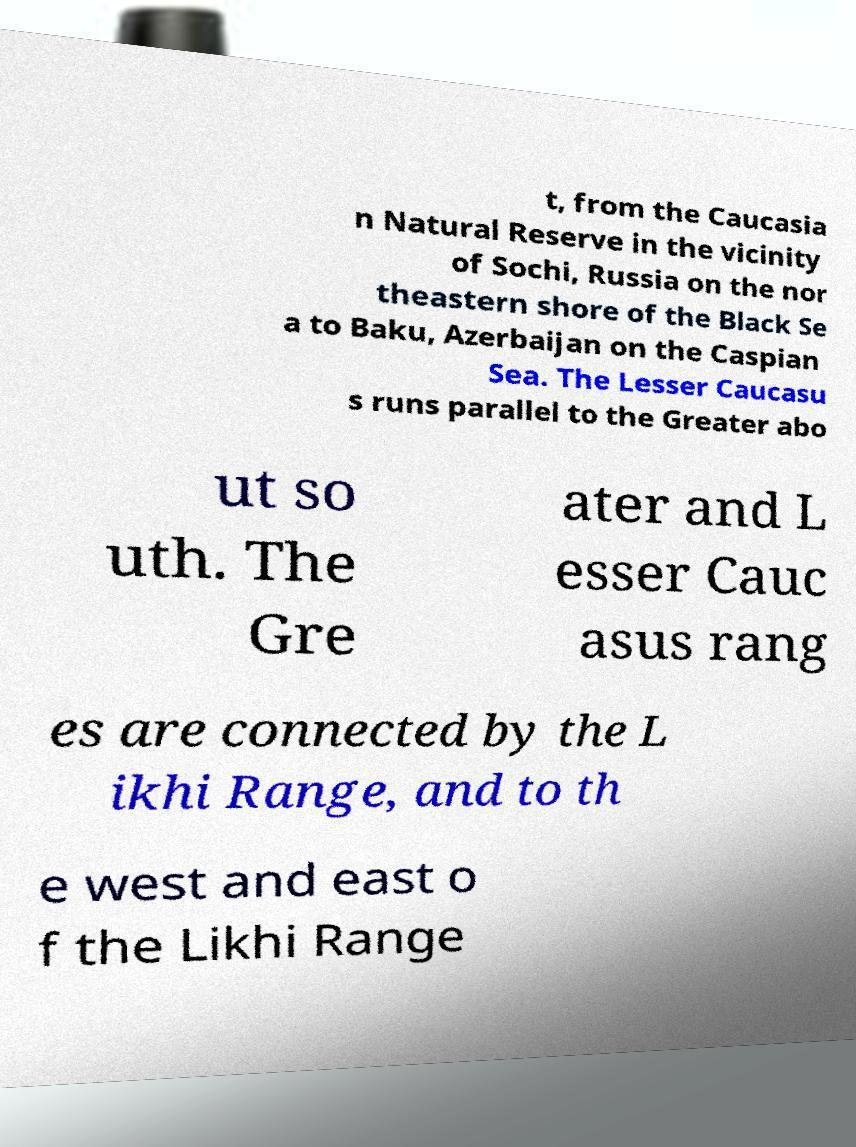Can you accurately transcribe the text from the provided image for me? t, from the Caucasia n Natural Reserve in the vicinity of Sochi, Russia on the nor theastern shore of the Black Se a to Baku, Azerbaijan on the Caspian Sea. The Lesser Caucasu s runs parallel to the Greater abo ut so uth. The Gre ater and L esser Cauc asus rang es are connected by the L ikhi Range, and to th e west and east o f the Likhi Range 